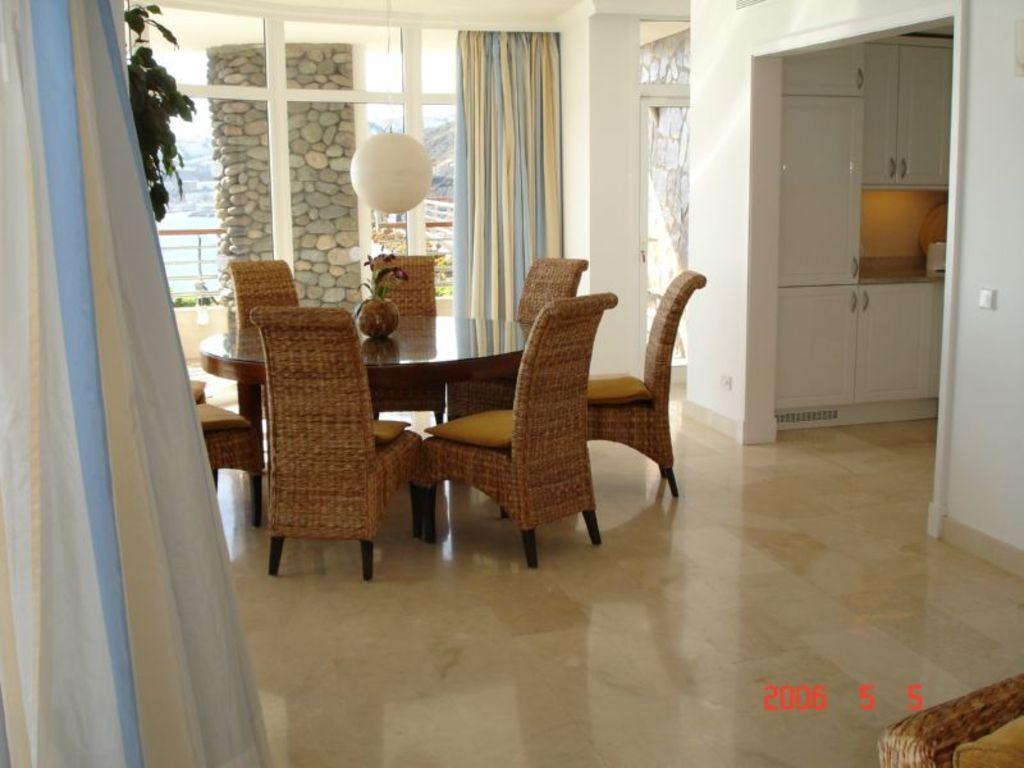How would you summarize this image in a sentence or two? This image is clicked inside a room. In the center there is a wooden table and chairs beside it. There is a flower vase on the table. Above to it there is a paper lantern hanging. Behind it there is a glass wall. There are curtains to the wall. To the right there is another room. There are cupboards to the wall in that room. To the left their leaves of a plants and curtain. Outside the glass wall there are pillars, a railing and house plants. Behind the railing there is water. In the bottom right there are numbers on the image. 